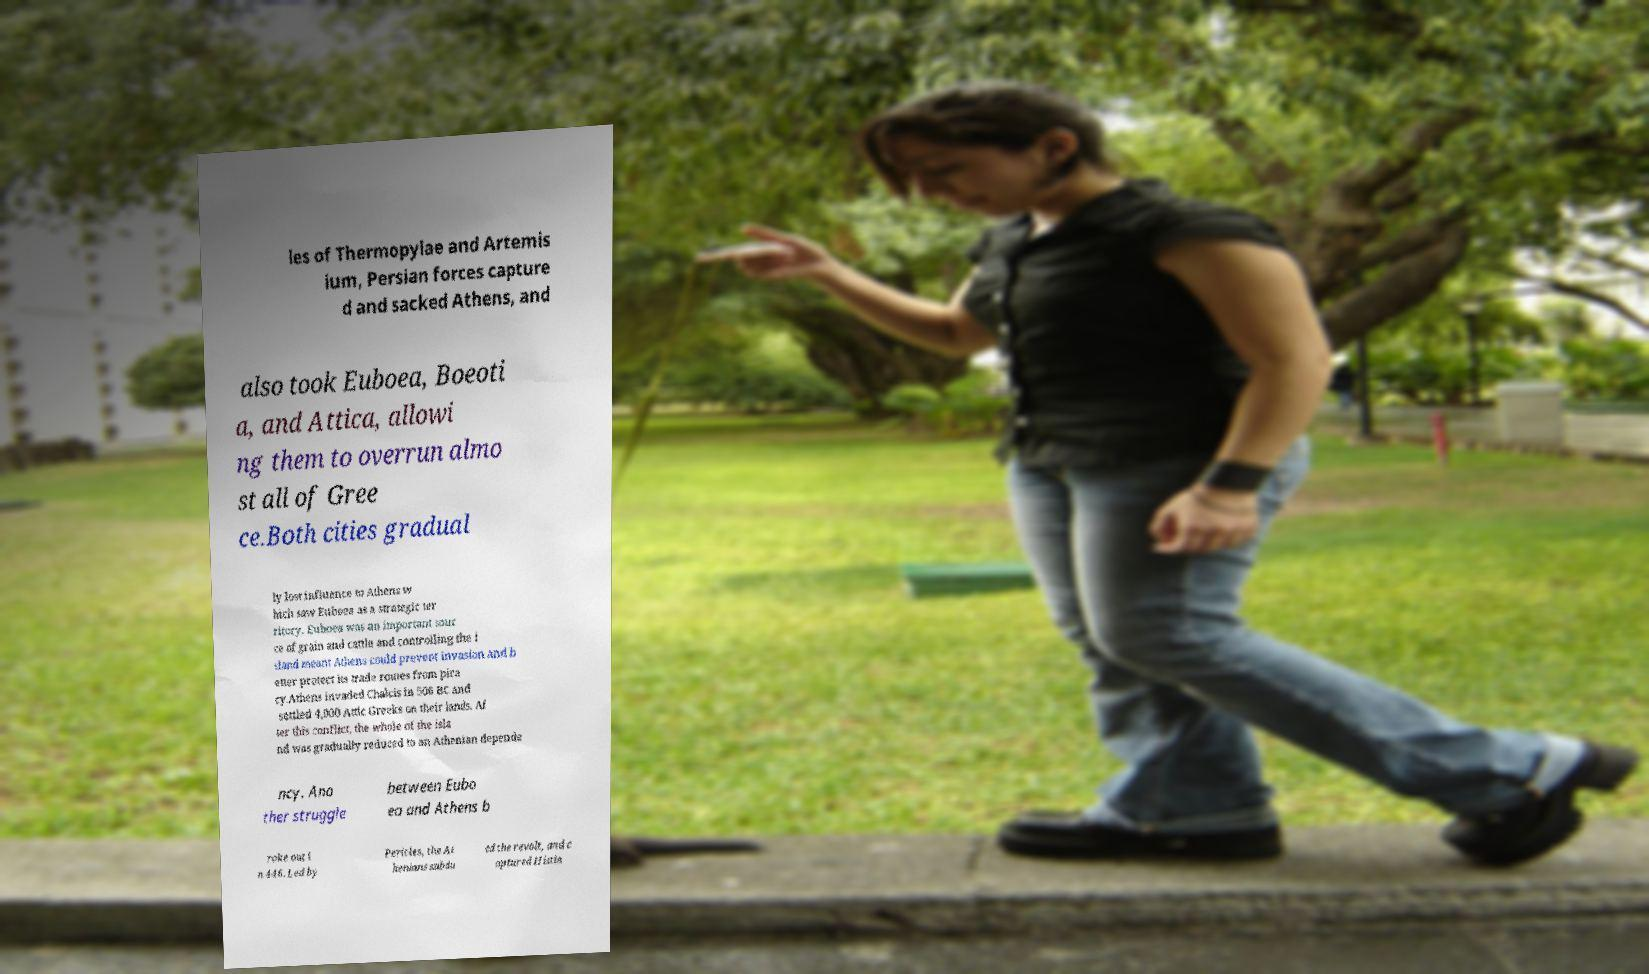I need the written content from this picture converted into text. Can you do that? les of Thermopylae and Artemis ium, Persian forces capture d and sacked Athens, and also took Euboea, Boeoti a, and Attica, allowi ng them to overrun almo st all of Gree ce.Both cities gradual ly lost influence to Athens w hich saw Euboea as a strategic ter ritory. Euboea was an important sour ce of grain and cattle and controlling the i sland meant Athens could prevent invasion and b etter protect its trade routes from pira cy.Athens invaded Chalcis in 506 BC and settled 4,000 Attic Greeks on their lands. Af ter this conflict, the whole of the isla nd was gradually reduced to an Athenian depende ncy. Ano ther struggle between Eubo ea and Athens b roke out i n 446. Led by Pericles, the At henians subdu ed the revolt, and c aptured Histia 